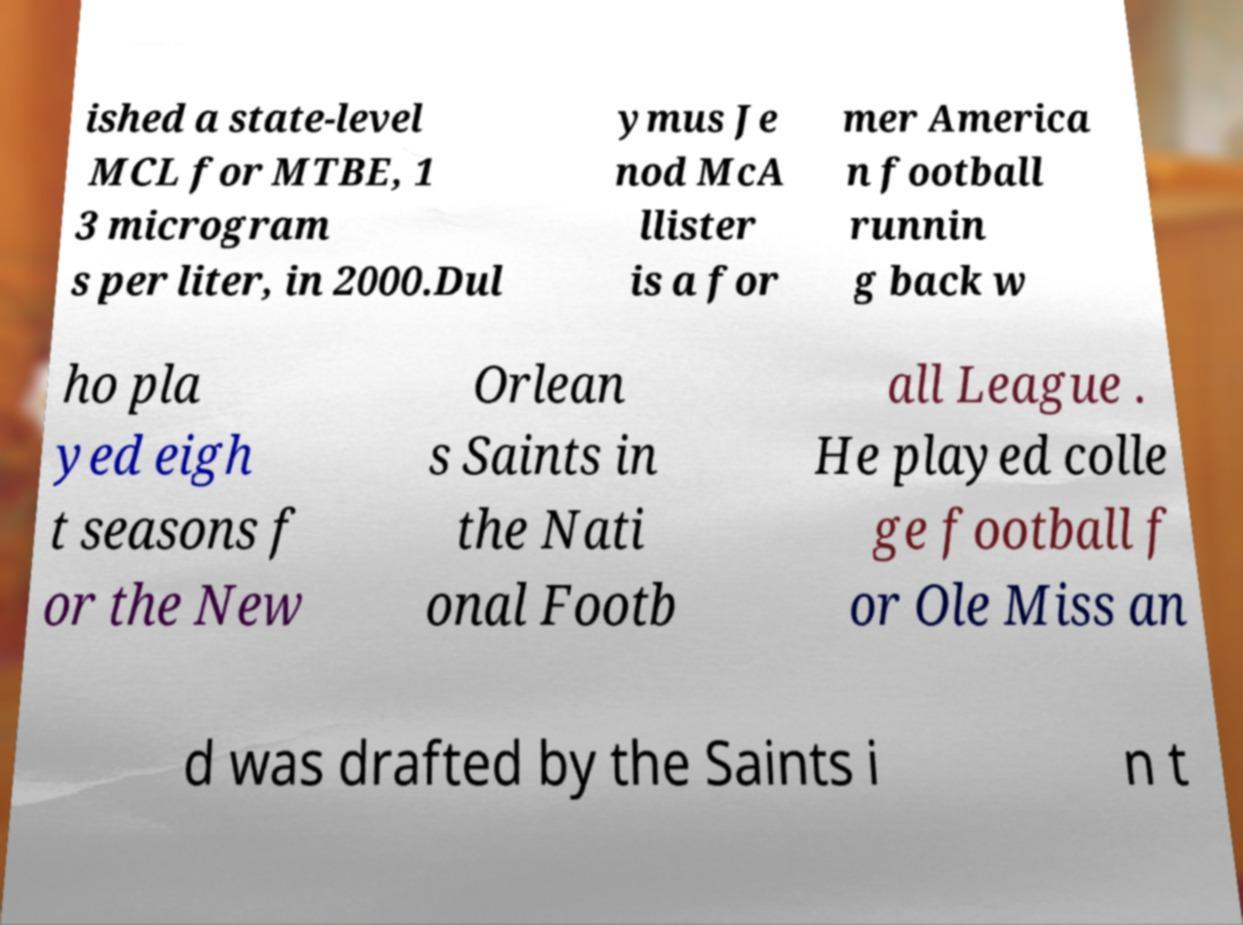Can you read and provide the text displayed in the image?This photo seems to have some interesting text. Can you extract and type it out for me? ished a state-level MCL for MTBE, 1 3 microgram s per liter, in 2000.Dul ymus Je nod McA llister is a for mer America n football runnin g back w ho pla yed eigh t seasons f or the New Orlean s Saints in the Nati onal Footb all League . He played colle ge football f or Ole Miss an d was drafted by the Saints i n t 